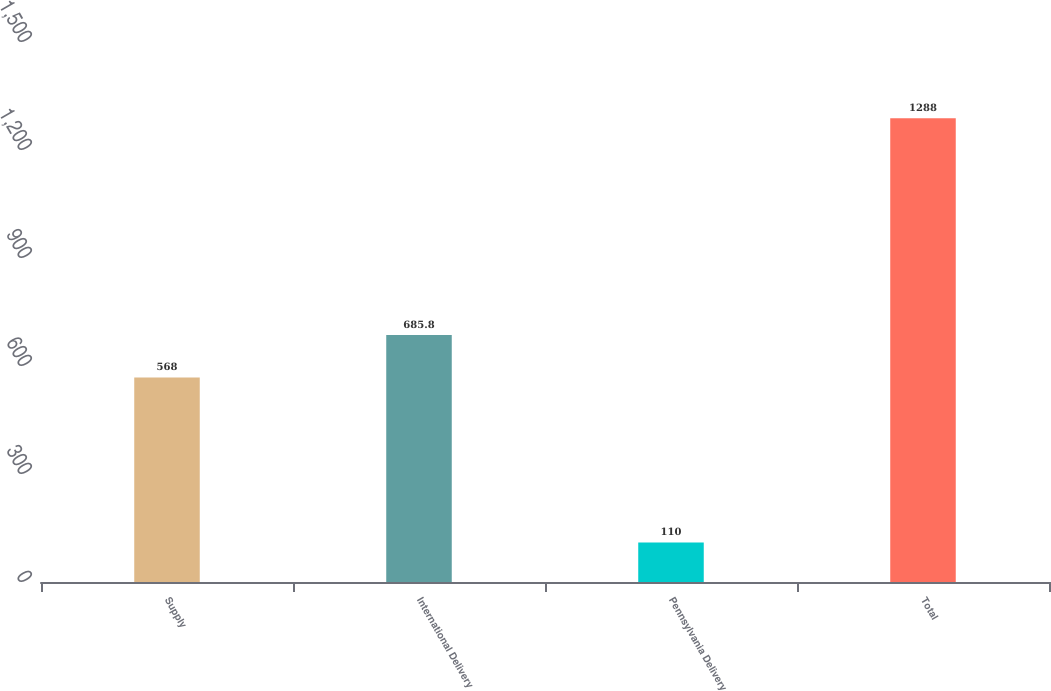Convert chart to OTSL. <chart><loc_0><loc_0><loc_500><loc_500><bar_chart><fcel>Supply<fcel>International Delivery<fcel>Pennsylvania Delivery<fcel>Total<nl><fcel>568<fcel>685.8<fcel>110<fcel>1288<nl></chart> 